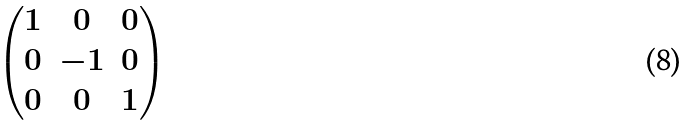Convert formula to latex. <formula><loc_0><loc_0><loc_500><loc_500>\begin{pmatrix} 1 & 0 & 0 \\ 0 & - 1 & 0 \\ 0 & 0 & 1 \end{pmatrix}</formula> 